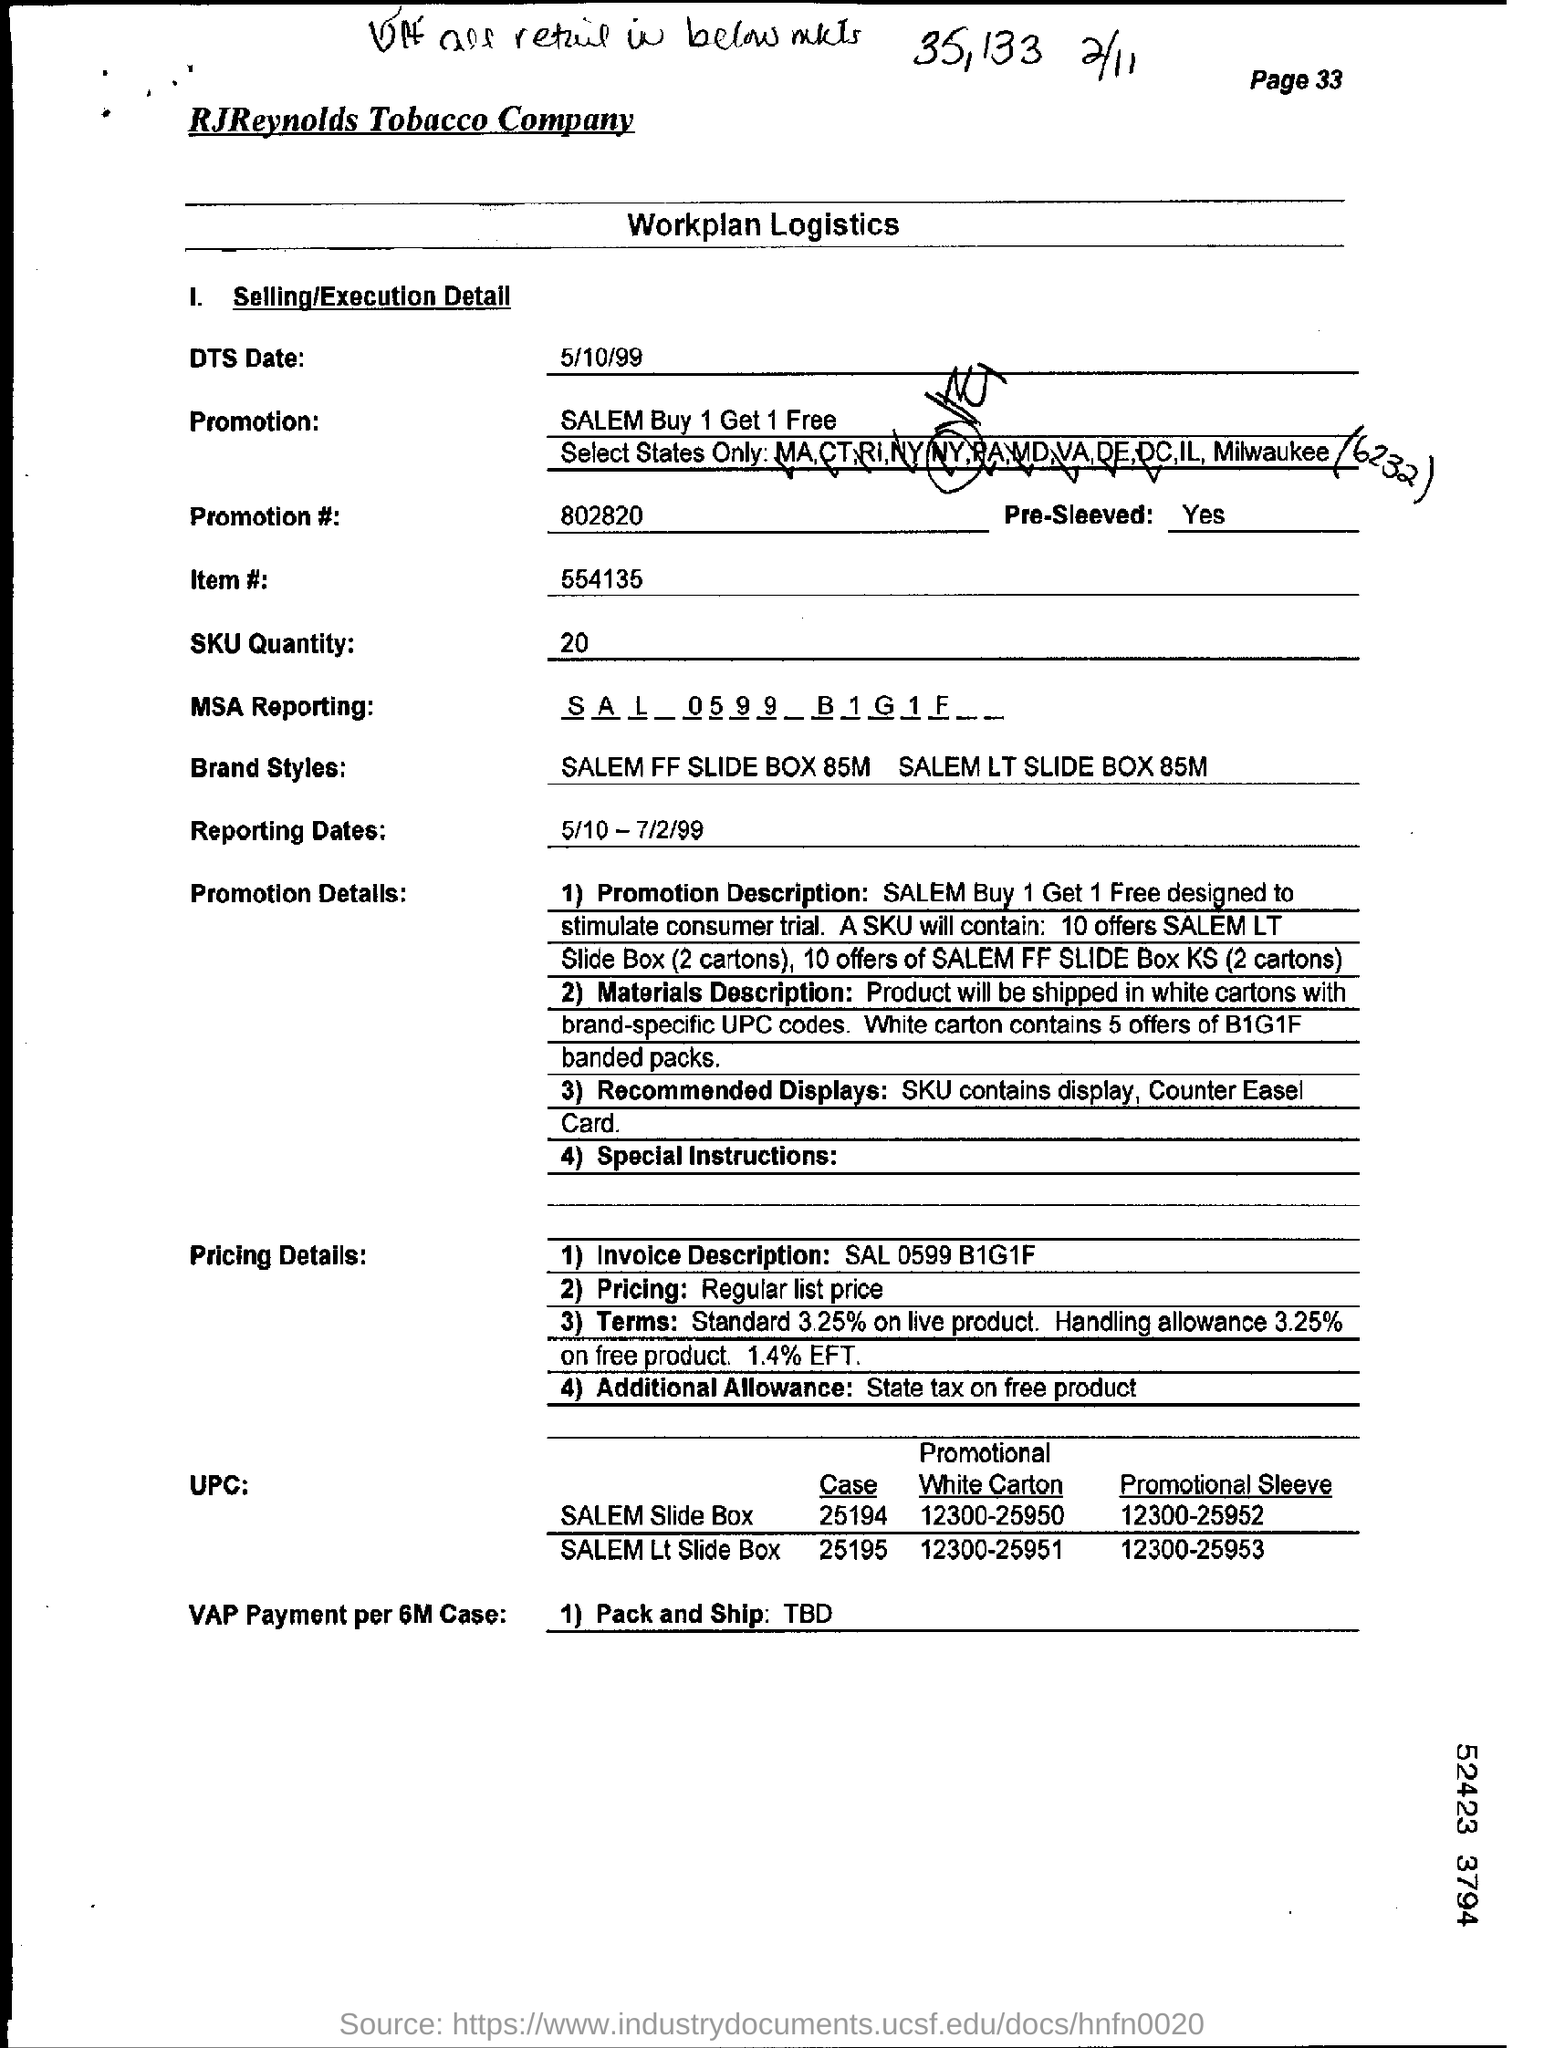What is name of company?
Ensure brevity in your answer.  RJReynolds Tobacco Company. DTS date mentioned?
Offer a terse response. 5/10/99. What is sku quantity ?
Provide a short and direct response. 20. What is the offer on product?
Your response must be concise. SALEM Buy 1 Get 1 Free. 